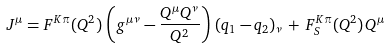<formula> <loc_0><loc_0><loc_500><loc_500>J ^ { \mu } = F ^ { K \pi } ( Q ^ { 2 } ) \, \left ( g ^ { \mu \nu } - \frac { Q ^ { \mu } Q ^ { \nu } } { Q ^ { 2 } } \right ) \, ( q _ { 1 } - q _ { 2 } ) _ { \nu } \, + \, F ^ { K \pi } _ { S } ( Q ^ { 2 } ) \, Q ^ { \mu }</formula> 